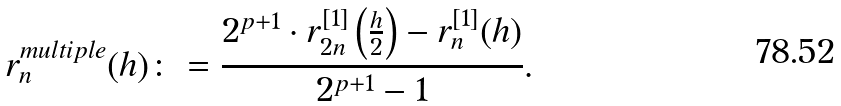Convert formula to latex. <formula><loc_0><loc_0><loc_500><loc_500>r _ { n } ^ { m u l t i p l e } ( h ) \colon = \frac { 2 ^ { p + 1 } \cdot r _ { 2 n } ^ { [ 1 ] } \left ( \frac { h } { 2 } \right ) - r _ { n } ^ { [ 1 ] } ( h ) } { 2 ^ { p + 1 } - 1 } .</formula> 